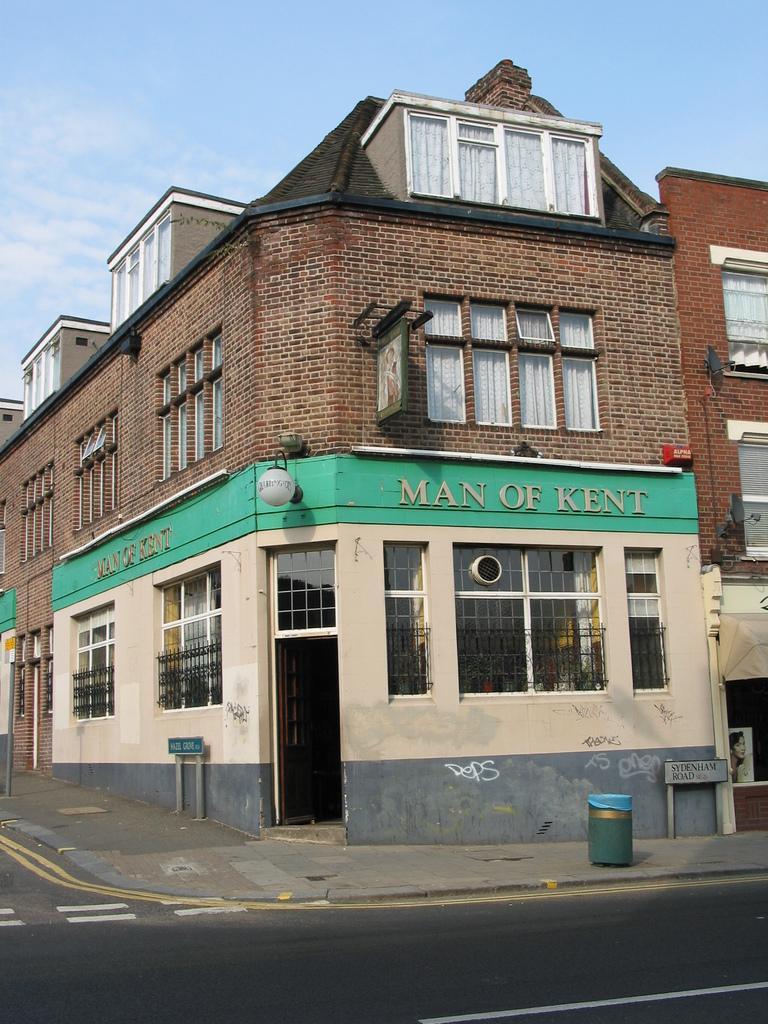Can you describe this image briefly? In this image I can see the building. In-front of the building I can see the road and the board. I can also see the dustbin to the side of the road. In the background I can see the blue sky. 